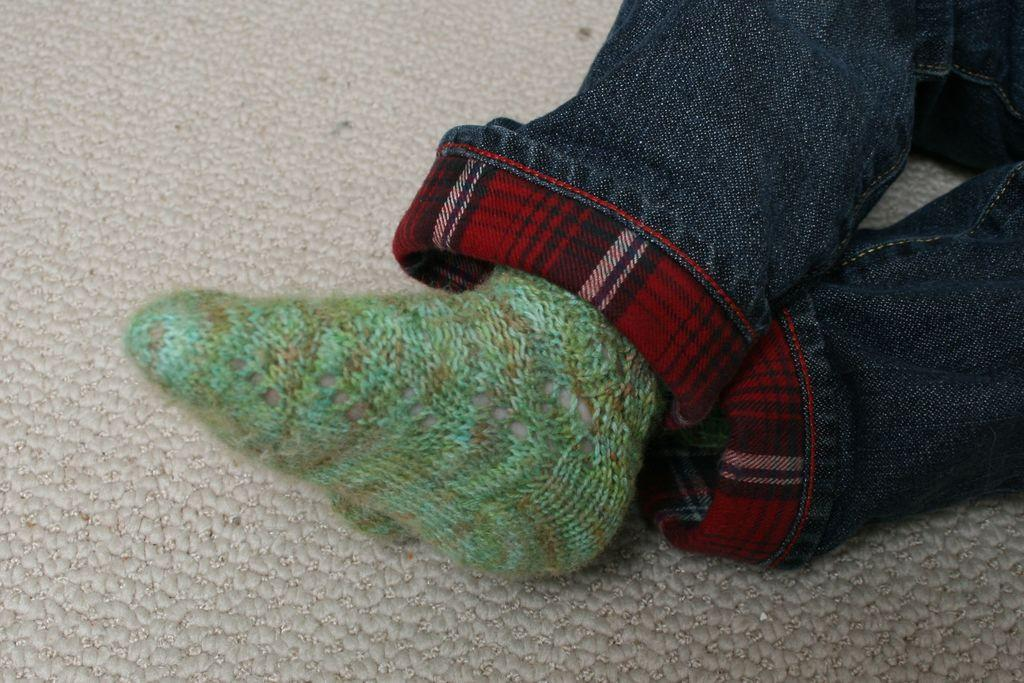What body parts are visible in the image? There are human legs visible in the image. What type of clothing is the person wearing on their feet? The person is wearing woolen socks. What can be seen in the background of the image? There is a carpet in the background of the image. What letters are being written on the coast in the image? There is no mention of letters or a coast in the image; it only features human legs and a carpet in the background. 